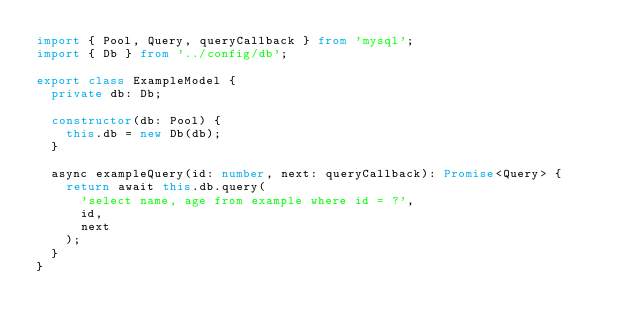Convert code to text. <code><loc_0><loc_0><loc_500><loc_500><_TypeScript_>import { Pool, Query, queryCallback } from 'mysql';
import { Db } from '../config/db';

export class ExampleModel {
  private db: Db;

  constructor(db: Pool) {
    this.db = new Db(db);
  }

  async exampleQuery(id: number, next: queryCallback): Promise<Query> {
    return await this.db.query(
      'select name, age from example where id = ?',
      id,
      next
    );
  }
}
</code> 